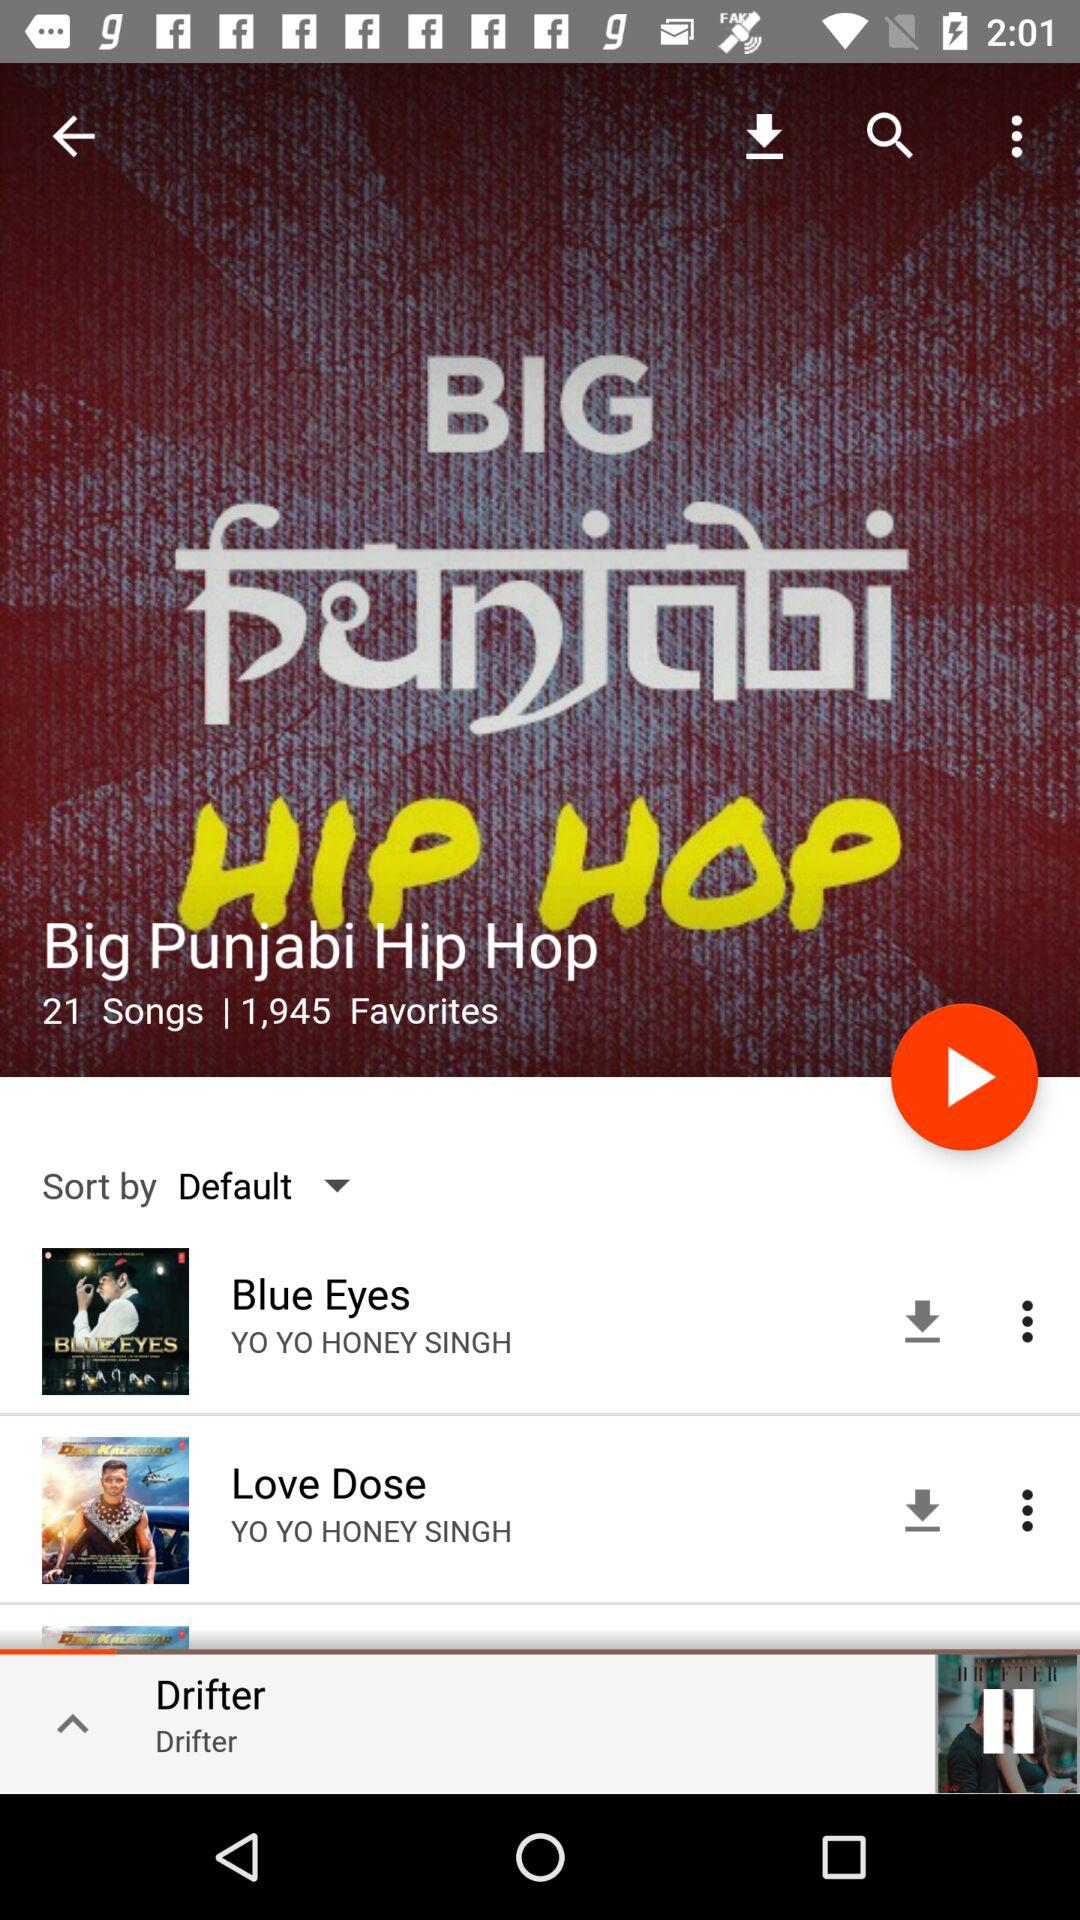Who is the singer of the "Love Dose" song? The singer of the "Love Dose" song is Yo Yo Honey Singh. 